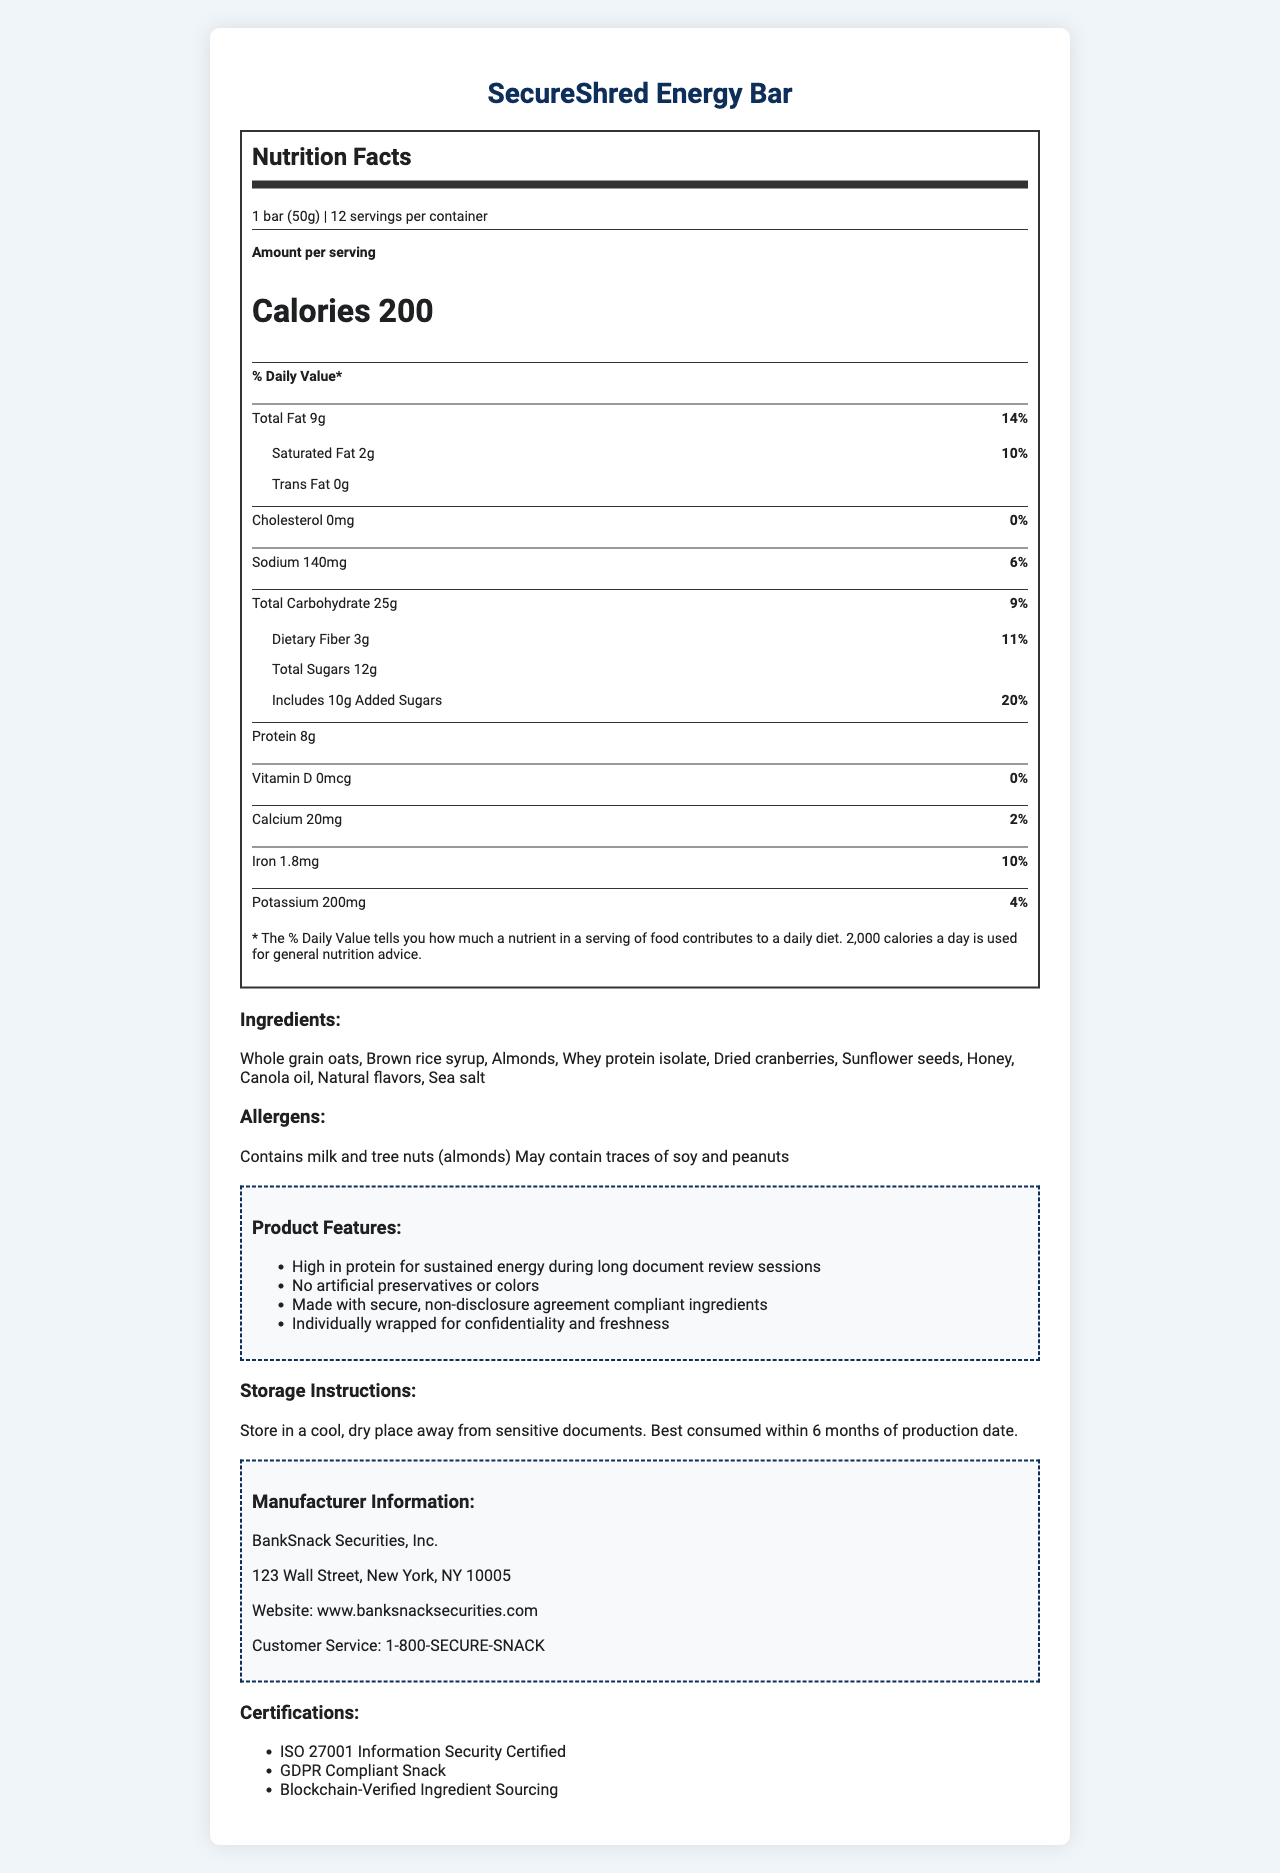what is the serving size of the SecureShred Energy Bar? The serving size is explicitly mentioned at the beginning of the nutrition label.
Answer: 1 bar (50g) how many calories are in one serving of the SecureShred Energy Bar? The number of calories per serving is prominently displayed in the "Calories" section.
Answer: 200 calories what percentage of the daily value of total fat does one serving provide? The total fat content is listed as 9 grams, which is 14% of the daily value based on a 2,000-calorie diet.
Answer: 14% how many grams of protein are in each serving? The protein content per serving is clearly stated in the nutrition facts.
Answer: 8 grams how many servings are there per container? The number of servings per container is listed right after the serving size.
Answer: 12 servings how much sodium does one bar contain? The sodium content is listed in the nutrition facts under the "Sodium" section.
Answer: 140 milligrams Which ingredient is NOT listed in the SecureShred Energy Bar? A. Almonds B. Honey C. Sugar D. Whey protein isolate The list of ingredients includes honey as a sweetener but does not explicitly mention sugar.
Answer: C. Sugar What percentage of the daily value for dietary fiber does one serving of SecureShred Energy Bar provide? A. 7% B. 11% C. 15% D. 18% The dietary fiber content per serving is 3 grams, which equates to 11% of the daily value.
Answer: C. 11% Is the SecureShred Energy Bar free from cholesterol? The document states that there are 0 milligrams of cholesterol in each serving.
Answer: Yes Summarize the main features and nutritional aspects of the SecureShred Energy Bar. This description covers the key nutritional information, ingredients, marketing claims, and storage instructions from the document.
Answer: The SecureShred Energy Bar is a high-protein snack (8 grams per serving) designed for sustained energy with 200 calories per serving. It contains 9 grams of total fat, 0 mg of cholesterol, and 140 mg of sodium. It also provides 25 grams of carbohydrates, including 3 grams of dietary fiber and 12 grams of sugars (10 grams added). Its ingredients include whole grain oats, almonds, whey protein isolate, and more. The product claims include no artificial preservatives or colors, GDPR compliance, and individual packaging for confidentiality. The bar should be stored in a cool, dry place. What is the exact amount of added sugars in one serving? The added sugars content is specified under the "Total Sugars" section of the nutrition label.
Answer: 10 grams What certifications does the SecureShred Energy Bar have? The certifications are listed towards the end of the document.
Answer: ISO 27001 Information Security Certified, GDPR Compliant Snack, Blockchain-Verified Ingredient Sourcing where was the SecureShred Energy Bar manufactured? The manufacturer's name and address are listed in the manufacturer information section.
Answer: BankSnack Securities, Inc., 123 Wall Street, New York, NY 10005 how much potassium does one serving provide? The potassium content is indicated in the nutrition label under "Potassium".
Answer: 200 milligrams are artificial preservatives or colors used in the SecureShred Energy Bar? One of the marketing claims explicitly mentions that there are no artificial preservatives or colors.
Answer: No Can you determine how long it has been since the SecureShred Energy Bar was produced? The document does not provide the production date, only that it should be consumed within 6 months.
Answer: Cannot be determined 